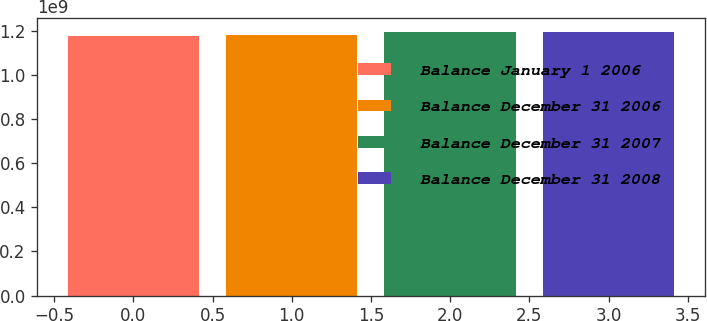Convert chart to OTSL. <chart><loc_0><loc_0><loc_500><loc_500><bar_chart><fcel>Balance January 1 2006<fcel>Balance December 31 2006<fcel>Balance December 31 2007<fcel>Balance December 31 2008<nl><fcel>1.1776e+09<fcel>1.17941e+09<fcel>1.1959e+09<fcel>1.1941e+09<nl></chart> 